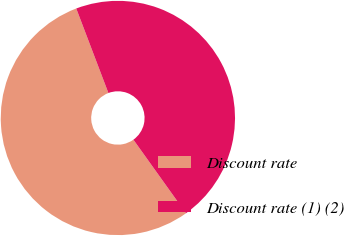Convert chart. <chart><loc_0><loc_0><loc_500><loc_500><pie_chart><fcel>Discount rate<fcel>Discount rate (1) (2)<nl><fcel>54.09%<fcel>45.91%<nl></chart> 